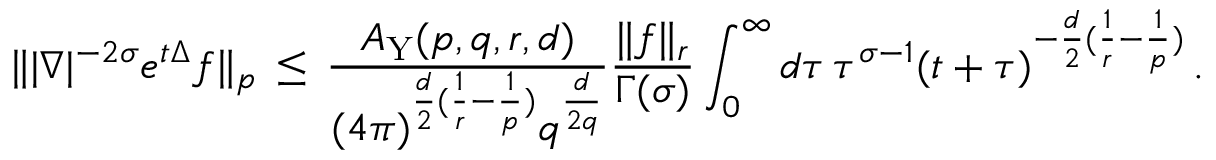<formula> <loc_0><loc_0><loc_500><loc_500>\| | \nabla | ^ { - 2 \sigma } e ^ { t \Delta } f \| _ { p } \, \leq \, \frac { A _ { Y } ( p , q , r , d ) } { ( 4 \pi ) ^ { \frac { d } 2 ( \frac { 1 } { r } - \frac { 1 } { p } ) } q ^ { \frac { d } { 2 q } } } \frac { \| f \| _ { r } } { \Gamma ( \sigma ) } \int _ { 0 } ^ { \infty } d \tau \, \tau ^ { \sigma - 1 } ( t + \tau ) ^ { - \frac { d } 2 ( \frac { 1 } { r } - \frac { 1 } { p } ) } \, .</formula> 